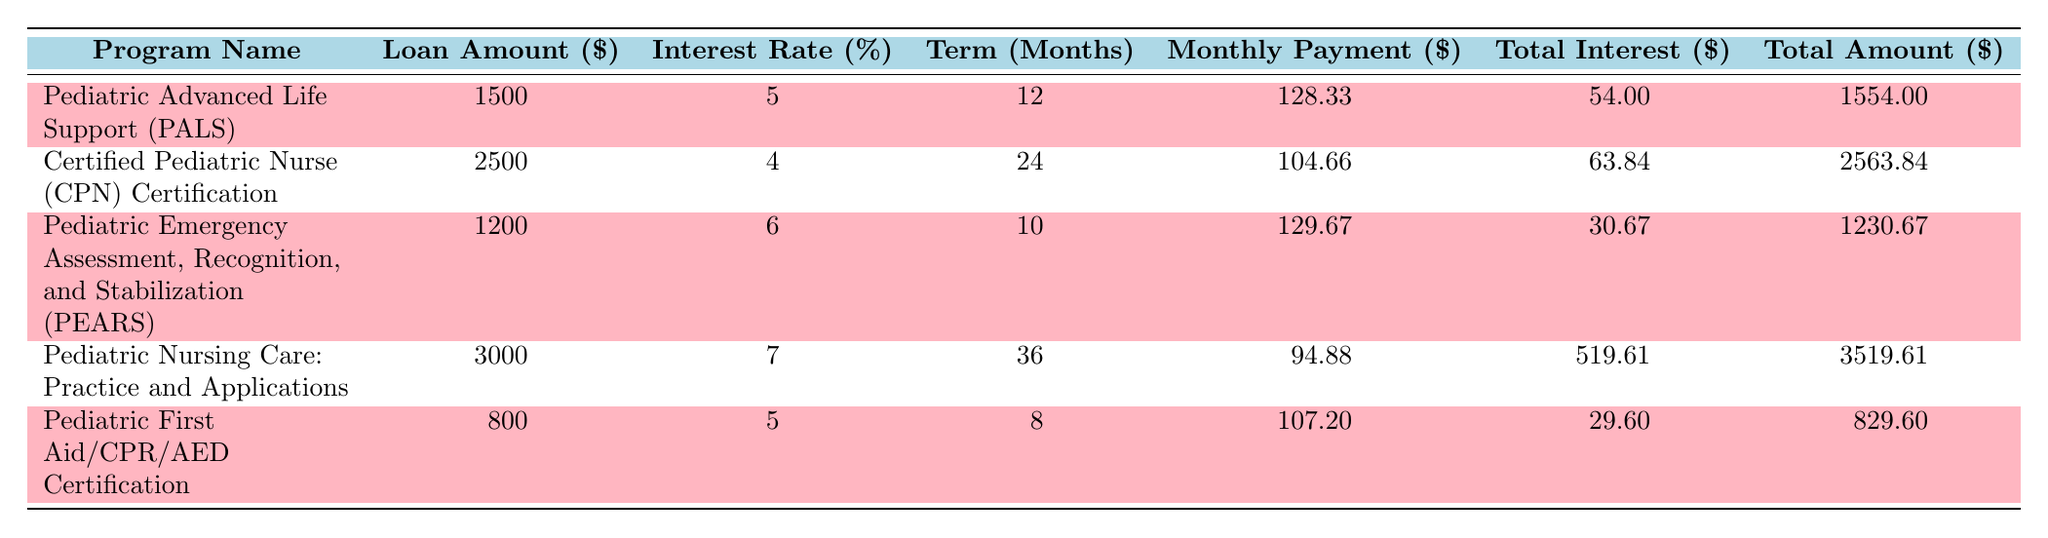What is the total loan amount for the Pediatric Nursing Care: Practice and Applications program? The table lists the total loan amount in the second column for each program. For the Pediatric Nursing Care: Practice and Applications program, the amount is found in the corresponding row, which is 3000.
Answer: 3000 Which program has the highest interest rate? By comparing the interest rates in the third column of the table, Pediatric Nursing Care: Practice and Applications has the highest rate at 7%.
Answer: 7% What is the average monthly payment across all programs? To find the average monthly payment, add all monthly payments: (128.33 + 104.66 + 129.67 + 94.88 + 107.20) = 564.74. There are 5 programs, so the average is 564.74 / 5 = 112.95.
Answer: 112.95 Is the total amount paid for the PALS program greater than the total amount paid for the PEARS program? The total amount paid for PALS is 1554.00 and for PEARS is 1230.67. Comparing both shows that 1554.00 is greater than 1230.67, so the statement is true.
Answer: Yes How much total interest will be paid for the Certified Pediatric Nurse Certification program? The total interest paid for this program is listed in the table under the "Total Interest" column, which is 63.84.
Answer: 63.84 What is the difference in total amount paid between the Pediatric First Aid/CPR/AED Certification and Pediatric Advanced Life Support programs? The total amount paid for Pediatric First Aid/CPR/AED Certification is 829.60, and for Pediatric Advanced Life Support, it is 1554.00. The difference is calculated as 1554.00 - 829.60 = 724.40.
Answer: 724.40 Is there any program listed with a loan term of 10 months? By examining the "Term" column, it can be observed that Pediatric Emergency Assessment, Recognition, and Stabilization has a term of 10 months. Therefore, the answer is yes.
Answer: Yes Which program requires the lowest monthly payment? By reviewing the "Monthly Payment" column, the lowest payment is found for the Pediatric Nursing Care: Practice and Applications program at 94.88.
Answer: 94.88 What is the total interest paid for all programs combined? To find the total interest, sum the individual interests: (54.00 + 63.84 + 30.67 + 519.61 + 29.60) = 697.72.
Answer: 697.72 